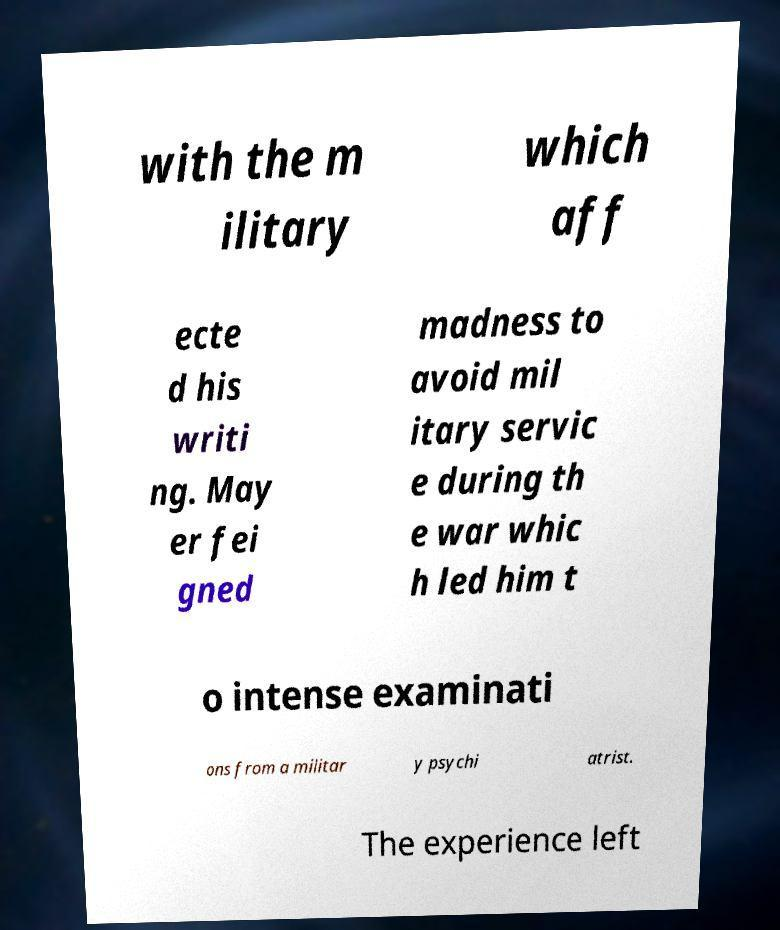For documentation purposes, I need the text within this image transcribed. Could you provide that? with the m ilitary which aff ecte d his writi ng. May er fei gned madness to avoid mil itary servic e during th e war whic h led him t o intense examinati ons from a militar y psychi atrist. The experience left 